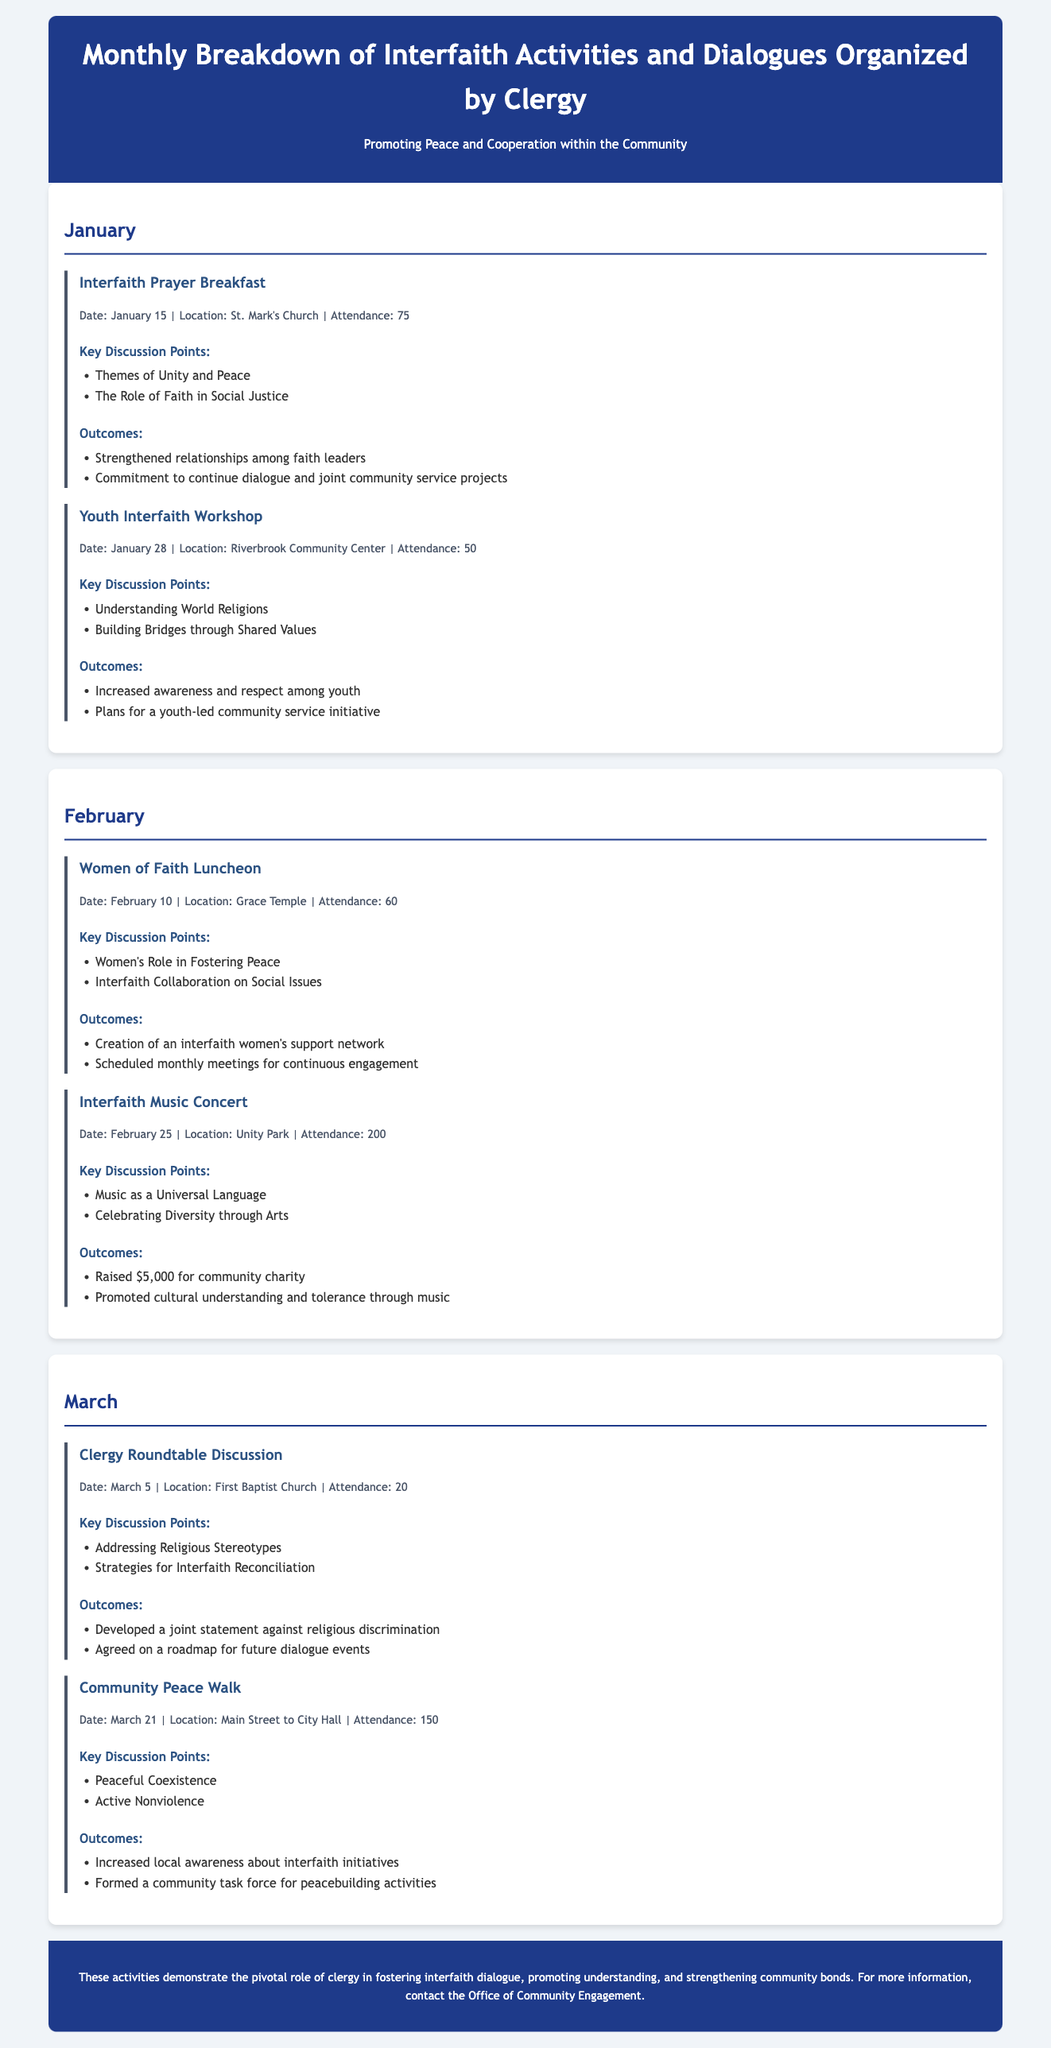what was the attendance for the Interfaith Prayer Breakfast? The attendance is listed in the document as 75 for the Interfaith Prayer Breakfast.
Answer: 75 which event took place on February 10? The event that took place on February 10 is the Women of Faith Luncheon.
Answer: Women of Faith Luncheon how much money was raised during the Interfaith Music Concert? The document states that $5,000 was raised during the Interfaith Music Concert.
Answer: $5,000 what were the key discussion points of the Youth Interfaith Workshop? The key discussion points of the Youth Interfaith Workshop were Understanding World Religions and Building Bridges through Shared Values.
Answer: Understanding World Religions, Building Bridges through Shared Values what was one outcome of the Community Peace Walk? One outcome of the Community Peace Walk was the formation of a community task force for peacebuilding activities.
Answer: Formed a community task force for peacebuilding activities 